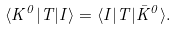<formula> <loc_0><loc_0><loc_500><loc_500>\langle K ^ { 0 } | T | I \rangle = \langle I | T | \bar { K } ^ { 0 } \rangle .</formula> 